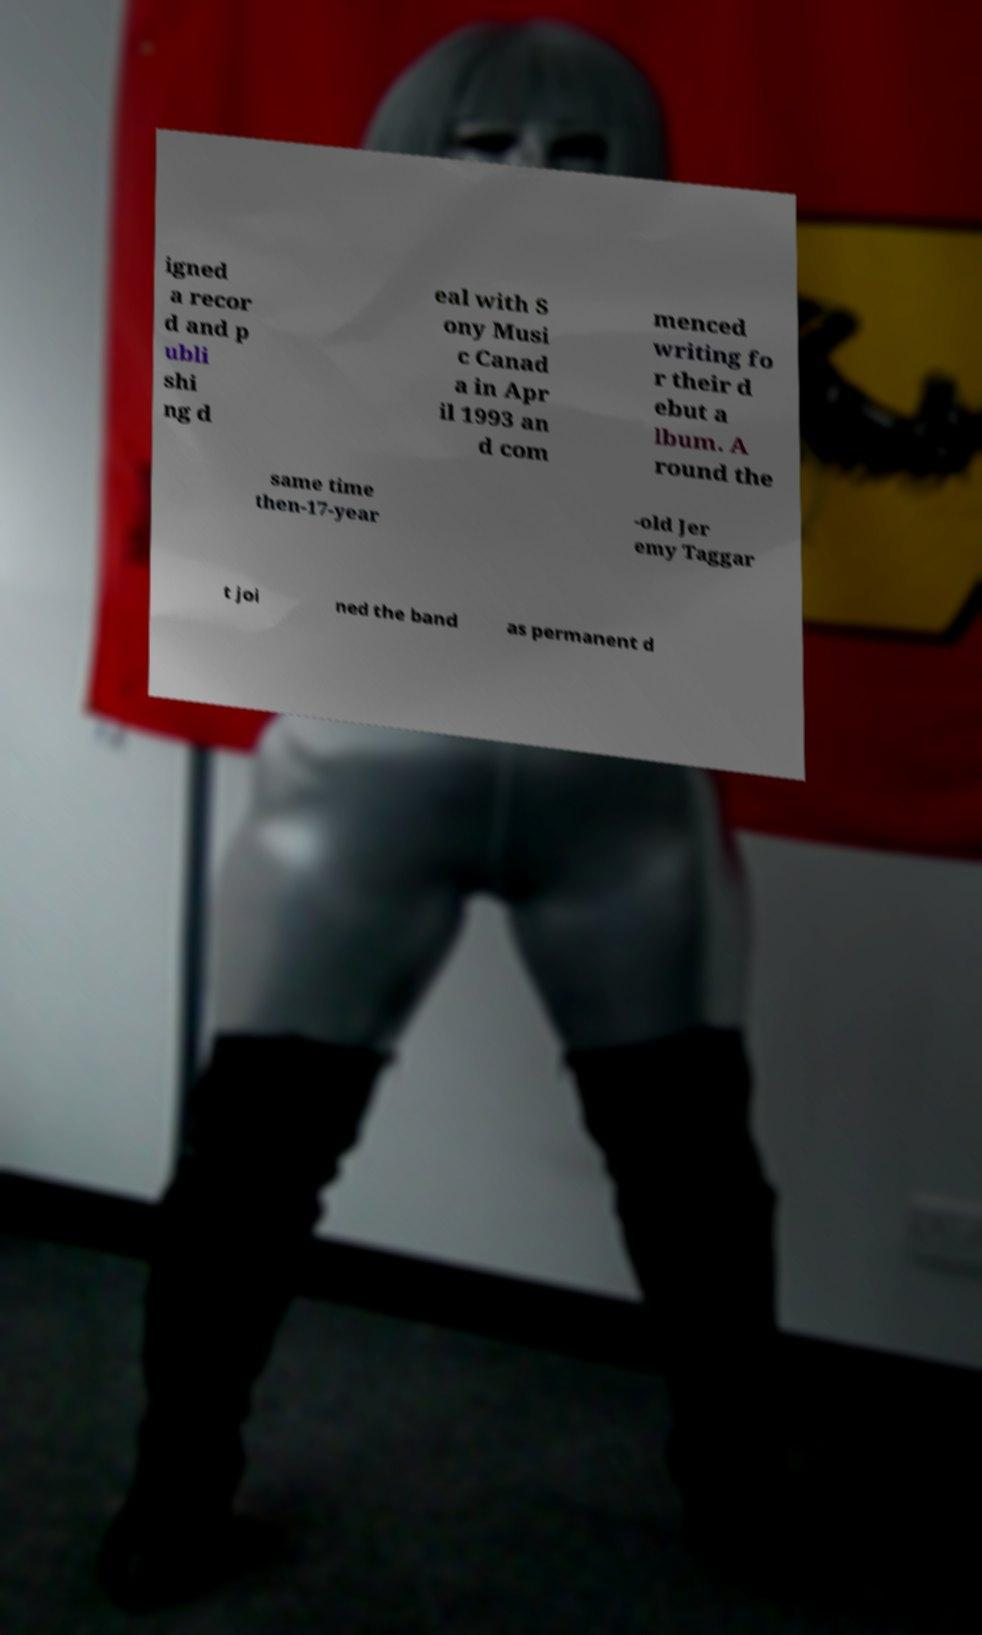I need the written content from this picture converted into text. Can you do that? igned a recor d and p ubli shi ng d eal with S ony Musi c Canad a in Apr il 1993 an d com menced writing fo r their d ebut a lbum. A round the same time then-17-year -old Jer emy Taggar t joi ned the band as permanent d 